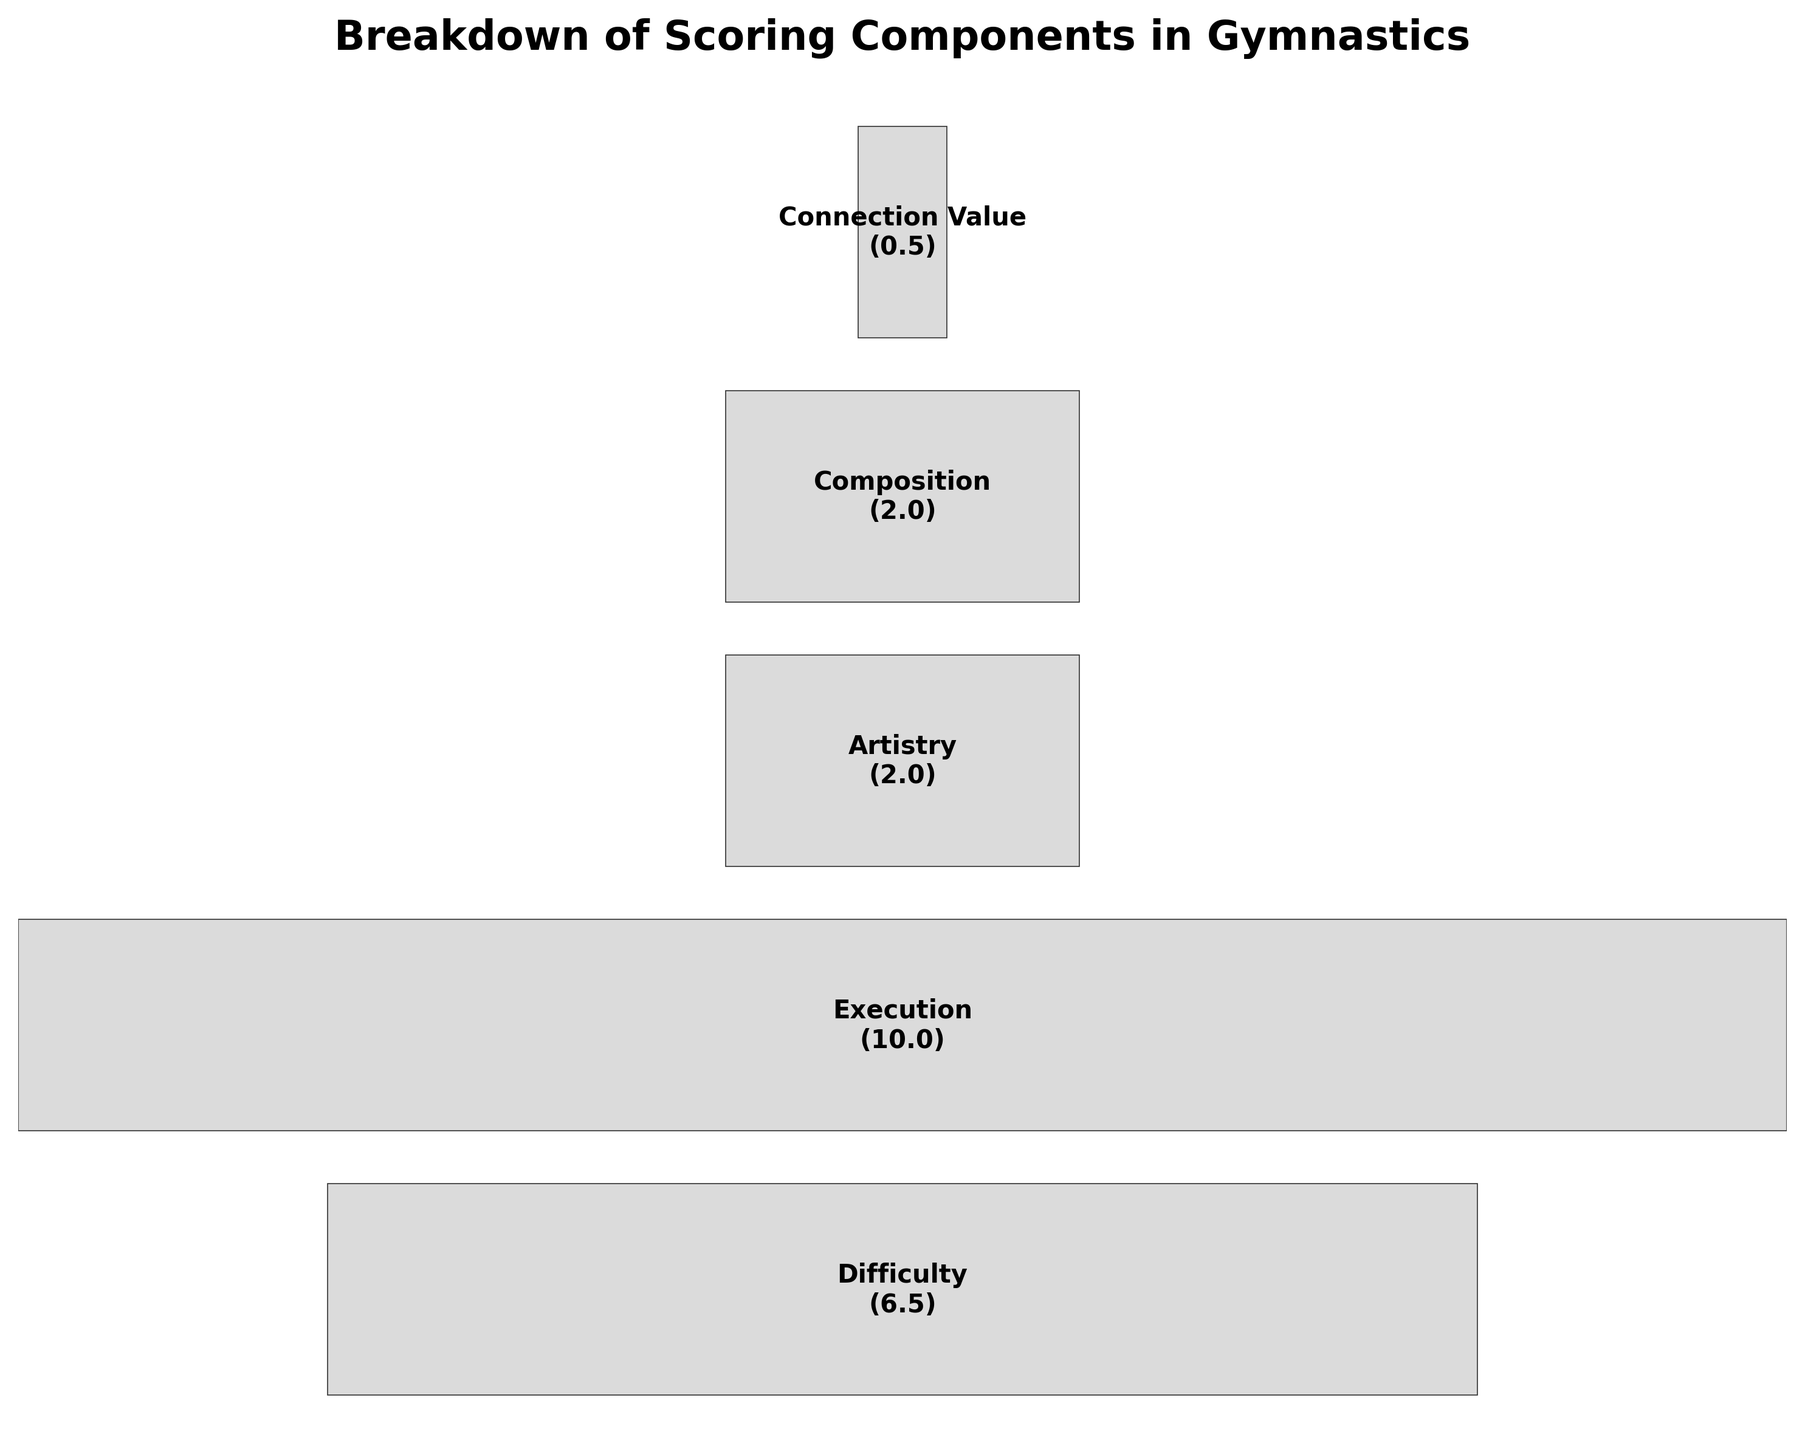What's the maximum score for the Execution component? The Execution component's score is displayed as part of the funnel chart. By looking at the "Execution" label on the chart, we can see its corresponding score.
Answer: 10.0 How are the widths of the bars determined in the funnel chart? The widths of the bars in the funnel chart are determined by dividing the score of each component by the maximum score (Execution, which is 10.0). This normalization ensures all values are relative to the largest component.
Answer: Scores are normalized to Execution's score What is the difference between the highest and lowest scoring components? The highest scoring component is Execution with a score of 10.0. The lowest scoring component is Connection Value with a score of 0.5. The difference is calculated as 10.0 - 0.5.
Answer: 9.5 Which components have a maximum score less than 2.0? By examining the funnel chart, we notice that Connection Value is the only component with a maximum score less than 2.0 (which is 0.5).
Answer: Connection Value Rank the components from highest to lowest based on their maximum score. The components are listed down the funnel chart from highest to lowest score. The order is Execution (10.0), Difficulty (6.5), Artistry (2.0), Composition (2.0), and Connection Value (0.5).
Answer: Execution > Difficulty > Artistry = Composition > Connection Value What's the total maximum score if all components are added up? Add the maximum scores of all components: Execution (10.0) + Difficulty (6.5) + Artistry (2.0) + Composition (2.0) + Connection Value (0.5).
Answer: 21.0 How many components have a maximum score of 2.0? By looking at the funnel chart, we can see that Artistry and Composition each have a maximum score of 2.0. Therefore, there are two such components.
Answer: 2 What is the median score of all components? To find the median score, first, list all the scores in ascending order: 0.5, 2.0, 2.0, 6.5, 10.0. The median is the middle value in this list, so we pick the third value.
Answer: 2.0 Which component is closest in score to the Artistry component? The Artistry component has a score of 2.0. The Composition component also has a score of 2.0, making it the closest in score.
Answer: Composition What percentage of the total maximum score does the Execution component contribute? The Execution component has a score of 10.0. The total maximum score for all components is 21.0. The percentage is calculated as (10.0 / 21.0) * 100.
Answer: 47.62 